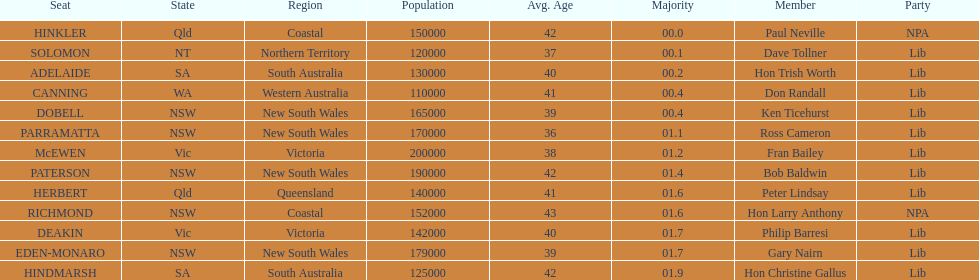Was fran bailey from victoria or western australia? Vic. 